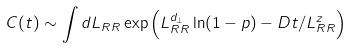<formula> <loc_0><loc_0><loc_500><loc_500>C ( t ) \sim \int d L _ { R R } \exp \left ( L _ { R R } ^ { d _ { \perp } } \ln ( 1 - p ) - D t / L _ { R R } ^ { z } \right )</formula> 